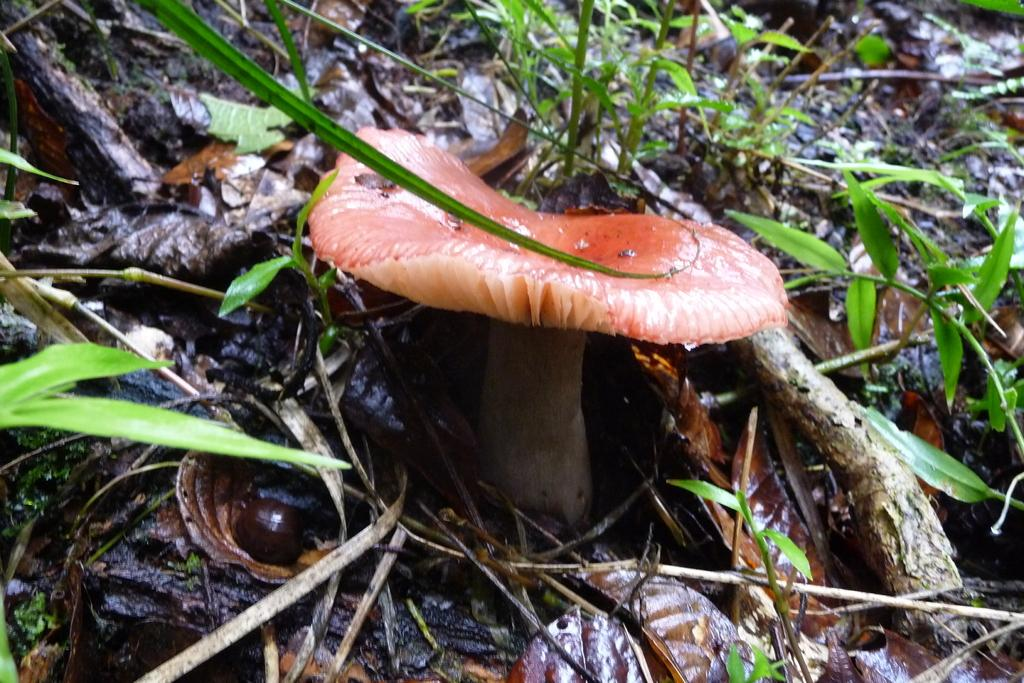What type of plant can be seen in the image? There is a mushroom in the image. What can be found on the ground in the image? There are dried twigs and leaves on the ground in the image. Are there any other plants visible in the image? Yes, there are small plants in the image. What type of oatmeal is being served in the image? There is no oatmeal present in the image; it features a mushroom, dried twigs, leaves, and small plants. 